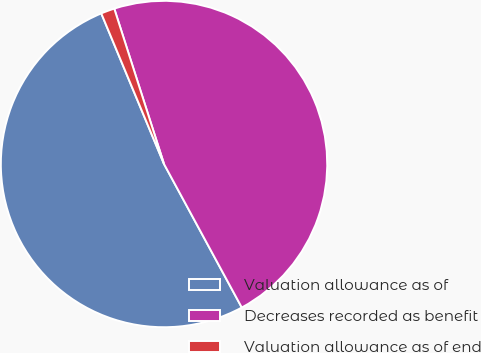Convert chart. <chart><loc_0><loc_0><loc_500><loc_500><pie_chart><fcel>Valuation allowance as of<fcel>Decreases recorded as benefit<fcel>Valuation allowance as of end<nl><fcel>51.62%<fcel>47.03%<fcel>1.35%<nl></chart> 